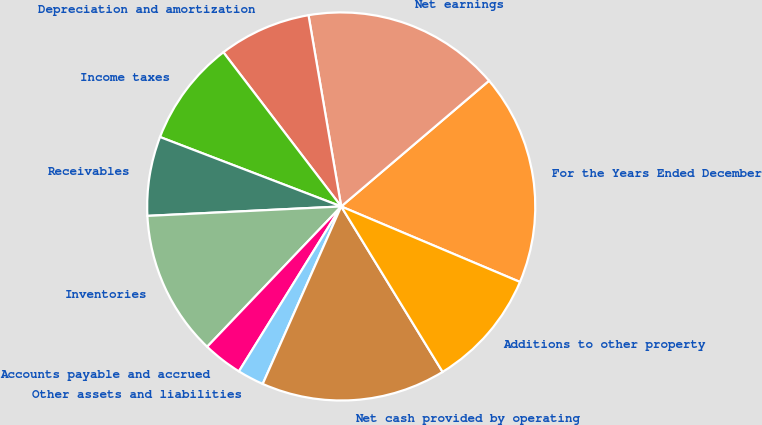Convert chart to OTSL. <chart><loc_0><loc_0><loc_500><loc_500><pie_chart><fcel>For the Years Ended December<fcel>Net earnings<fcel>Depreciation and amortization<fcel>Income taxes<fcel>Receivables<fcel>Inventories<fcel>Accounts payable and accrued<fcel>Other assets and liabilities<fcel>Net cash provided by operating<fcel>Additions to other property<nl><fcel>17.58%<fcel>16.48%<fcel>7.69%<fcel>8.79%<fcel>6.6%<fcel>12.09%<fcel>3.3%<fcel>2.21%<fcel>15.38%<fcel>9.89%<nl></chart> 